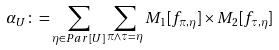Convert formula to latex. <formula><loc_0><loc_0><loc_500><loc_500>\alpha _ { U } \colon = \sum _ { \eta \in P a r [ U ] } \sum _ { \pi \wedge \tau = \eta } M _ { 1 } [ f _ { \pi , \eta } ] \times M _ { 2 } [ f _ { \tau , \eta } ]</formula> 